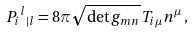<formula> <loc_0><loc_0><loc_500><loc_500>P _ { i } { ^ { l } } { _ { | l } } = 8 \pi \sqrt { \det g _ { m n } } \, T _ { i \mu } n ^ { \mu } \, ,</formula> 